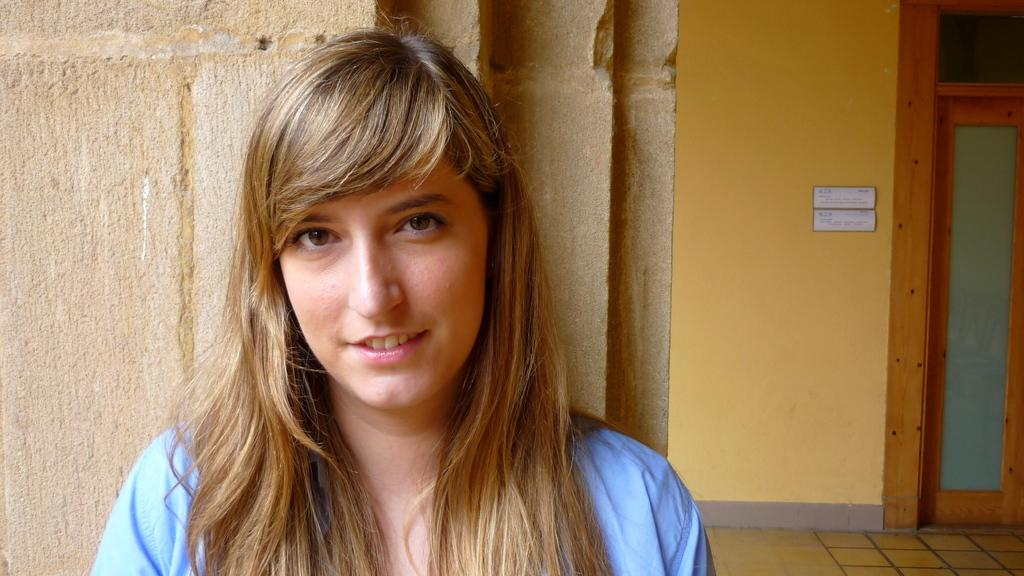What is the person in the image wearing? The person in the image is wearing a blue dress. What can be seen in the background of the image? There is a yellow color wall and boards on the wall in the background. Where is the door located in the image? The door is located to the right side of the image. Are there any flowers visible in the image? No, there are no flowers present in the image. What type of class is being held in the image? There is no indication of a class being held in the image. 